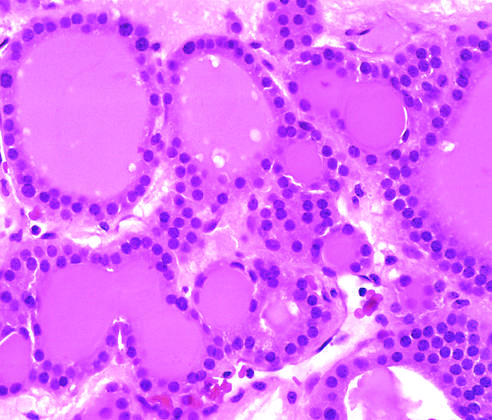what is visible in this gross specimen?
Answer the question using a single word or phrase. A solitary 